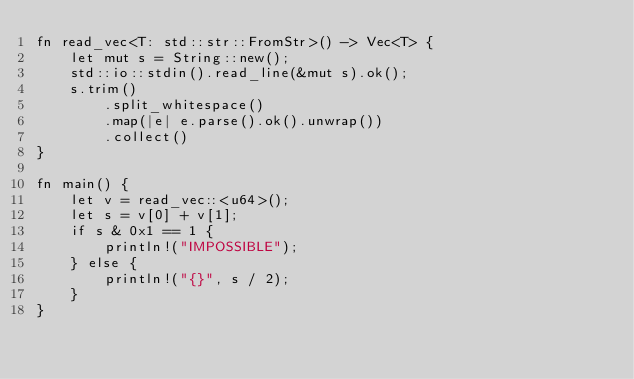<code> <loc_0><loc_0><loc_500><loc_500><_Rust_>fn read_vec<T: std::str::FromStr>() -> Vec<T> {
    let mut s = String::new();
    std::io::stdin().read_line(&mut s).ok();
    s.trim()
        .split_whitespace()
        .map(|e| e.parse().ok().unwrap())
        .collect()
}

fn main() {
    let v = read_vec::<u64>();
    let s = v[0] + v[1];
    if s & 0x1 == 1 {
        println!("IMPOSSIBLE");
    } else {
        println!("{}", s / 2);
    }
}
</code> 